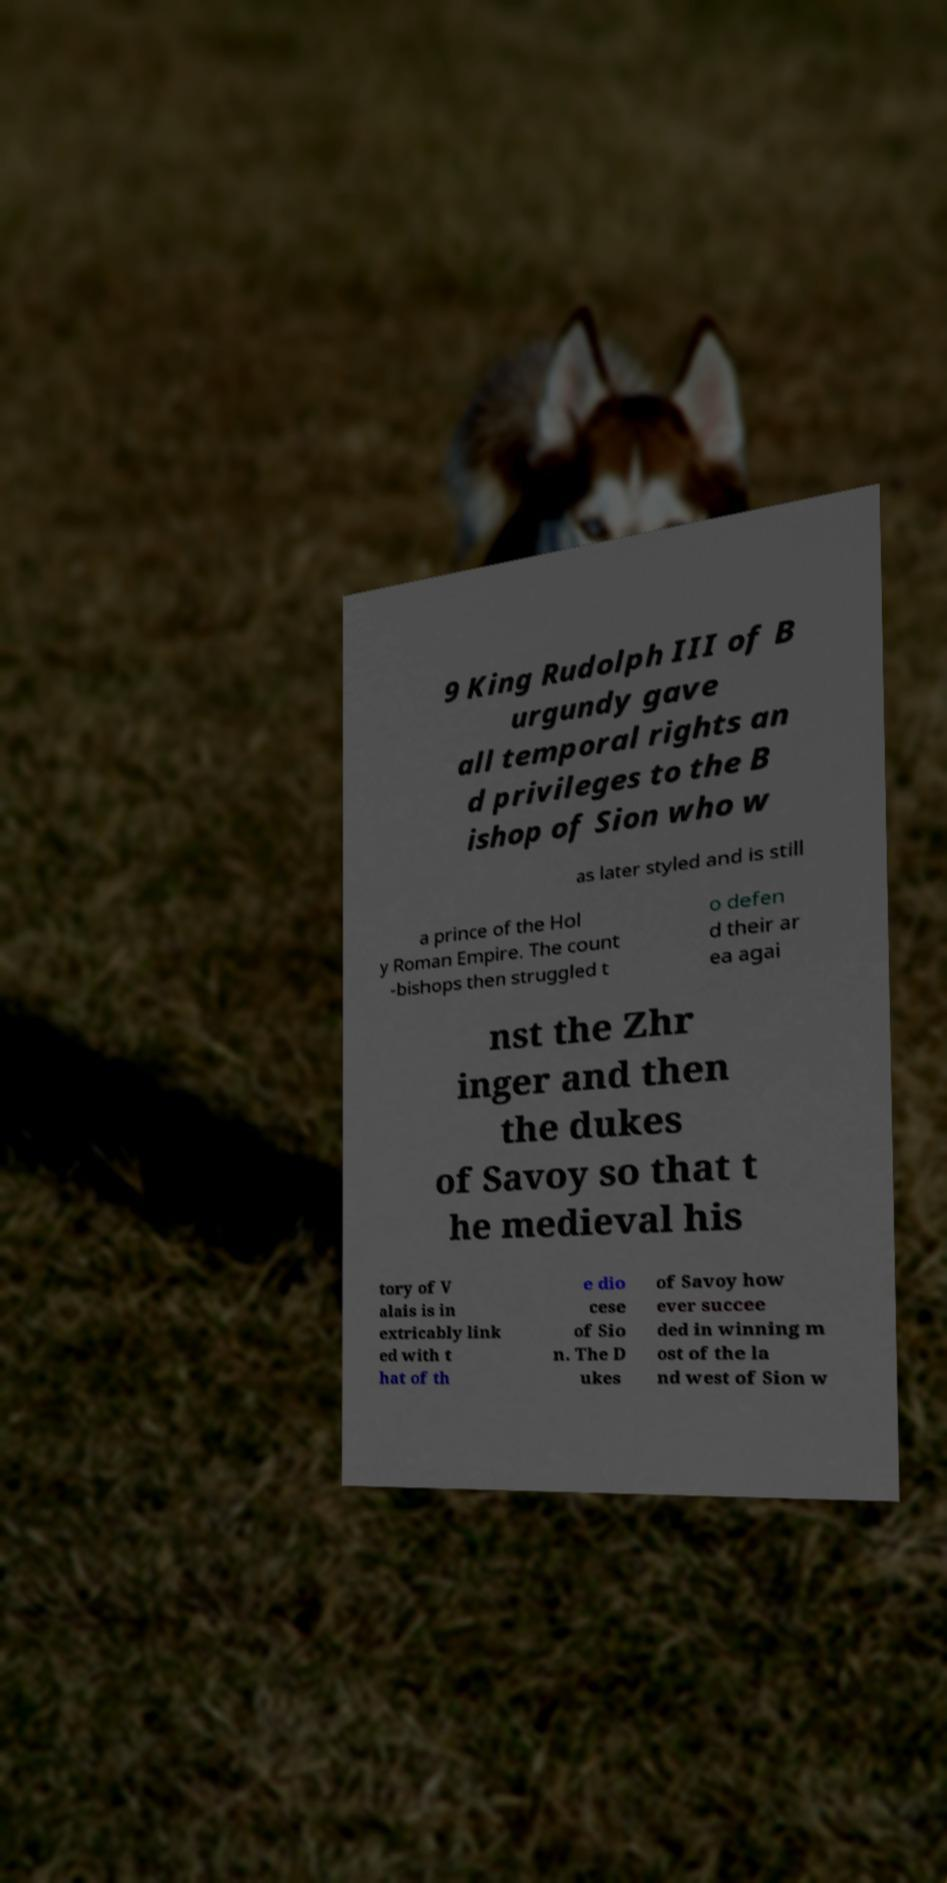Can you read and provide the text displayed in the image?This photo seems to have some interesting text. Can you extract and type it out for me? 9 King Rudolph III of B urgundy gave all temporal rights an d privileges to the B ishop of Sion who w as later styled and is still a prince of the Hol y Roman Empire. The count -bishops then struggled t o defen d their ar ea agai nst the Zhr inger and then the dukes of Savoy so that t he medieval his tory of V alais is in extricably link ed with t hat of th e dio cese of Sio n. The D ukes of Savoy how ever succee ded in winning m ost of the la nd west of Sion w 